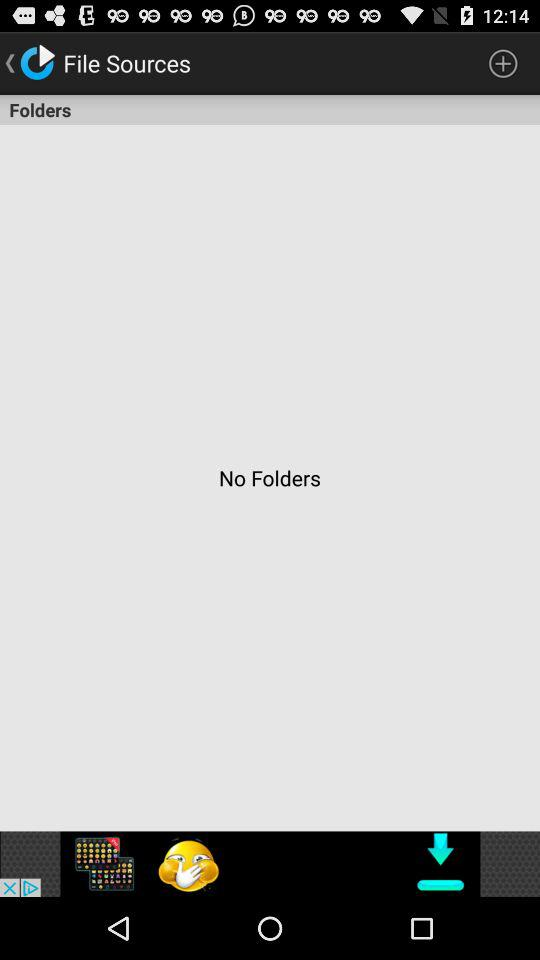How many folders in total are there? There are no folders. 